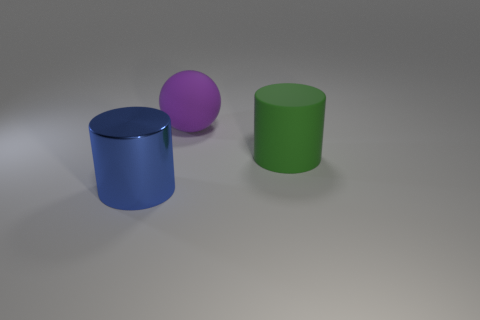How many other large things have the same shape as the big shiny object?
Ensure brevity in your answer.  1. There is a large object that is right of the object behind the big green cylinder; what color is it?
Keep it short and to the point. Green. Do the purple thing and the thing right of the big purple ball have the same shape?
Your answer should be compact. No. How many purple matte spheres are the same size as the green rubber thing?
Provide a succinct answer. 1. There is another thing that is the same shape as the green rubber thing; what material is it?
Provide a succinct answer. Metal. The large matte thing behind the green rubber cylinder has what shape?
Keep it short and to the point. Sphere. What color is the rubber sphere?
Your answer should be very brief. Purple. The other large object that is the same material as the large green thing is what shape?
Provide a succinct answer. Sphere. There is a object that is in front of the rubber cylinder; does it have the same size as the big purple sphere?
Your answer should be very brief. Yes. How many objects are rubber objects that are behind the big green cylinder or cylinders that are right of the large blue thing?
Ensure brevity in your answer.  2. 